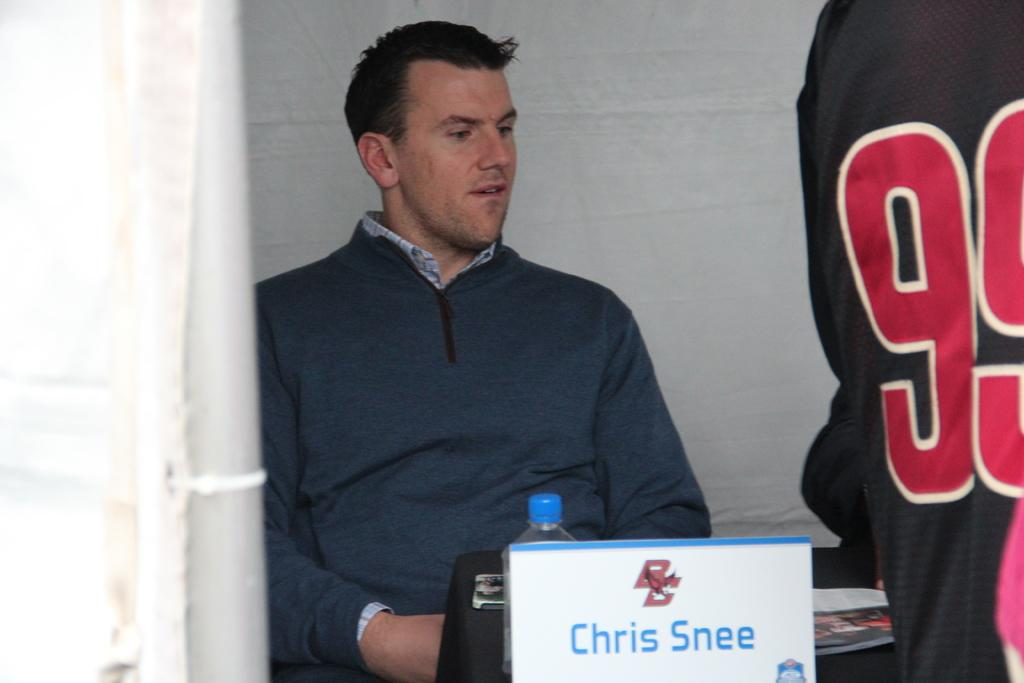<image>
Describe the image concisely. Man sitting behind a sign with the name Chris Snee on it. 